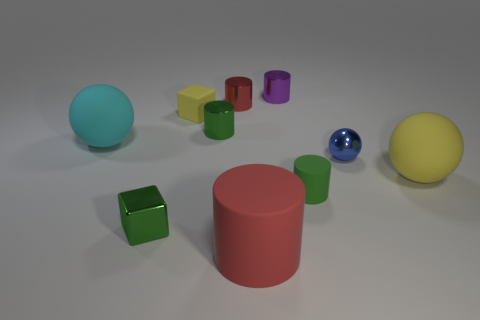Subtract all big balls. How many balls are left? 1 Subtract 2 cylinders. How many cylinders are left? 3 Subtract all purple cylinders. How many cylinders are left? 4 Subtract all cyan cylinders. Subtract all green spheres. How many cylinders are left? 5 Subtract all balls. How many objects are left? 7 Add 8 big gray metallic objects. How many big gray metallic objects exist? 8 Subtract 0 gray cylinders. How many objects are left? 10 Subtract all large cyan rubber balls. Subtract all green shiny cubes. How many objects are left? 8 Add 1 tiny yellow blocks. How many tiny yellow blocks are left? 2 